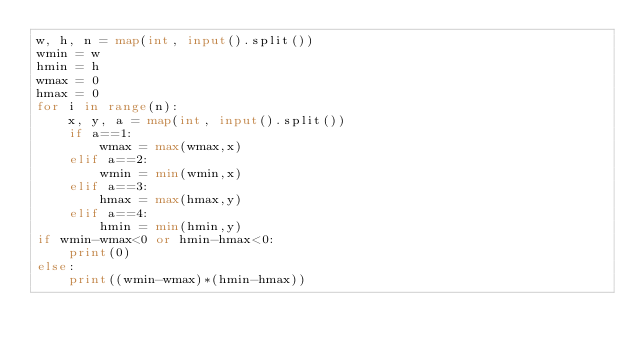Convert code to text. <code><loc_0><loc_0><loc_500><loc_500><_Python_>w, h, n = map(int, input().split())
wmin = w
hmin = h
wmax = 0
hmax = 0
for i in range(n):
    x, y, a = map(int, input().split())
    if a==1:
        wmax = max(wmax,x)
    elif a==2:
        wmin = min(wmin,x)
    elif a==3:
        hmax = max(hmax,y)
    elif a==4:
        hmin = min(hmin,y)
if wmin-wmax<0 or hmin-hmax<0:
    print(0)
else:
    print((wmin-wmax)*(hmin-hmax))
    </code> 